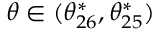<formula> <loc_0><loc_0><loc_500><loc_500>\theta \in ( \theta _ { 2 6 } ^ { * } , \theta _ { 2 5 } ^ { * } )</formula> 